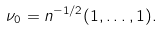Convert formula to latex. <formula><loc_0><loc_0><loc_500><loc_500>\nu _ { 0 } = n ^ { - 1 / 2 } ( 1 , \dots , 1 ) .</formula> 